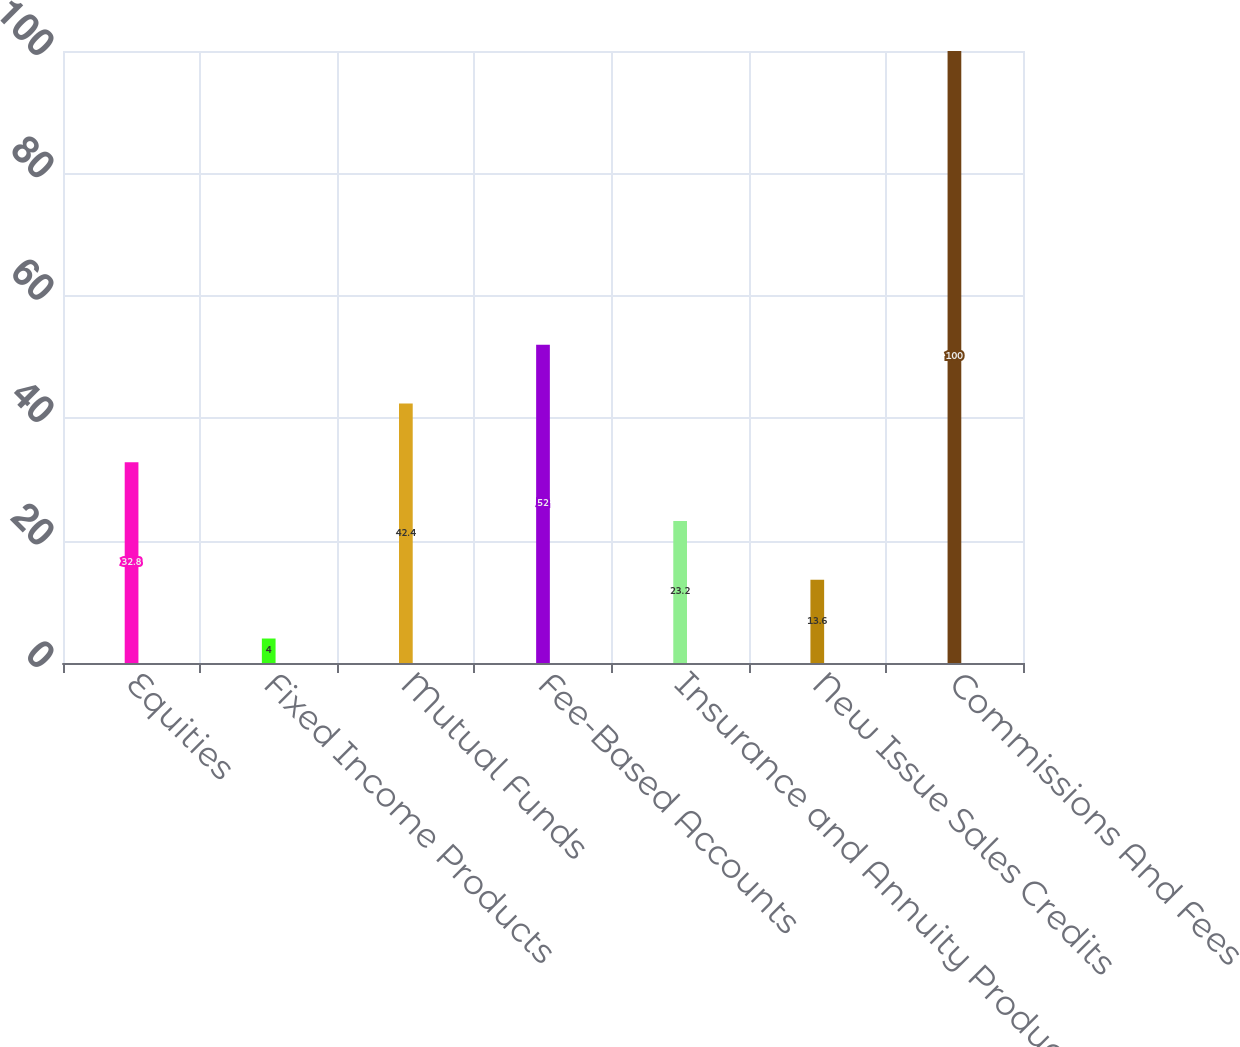Convert chart to OTSL. <chart><loc_0><loc_0><loc_500><loc_500><bar_chart><fcel>Equities<fcel>Fixed Income Products<fcel>Mutual Funds<fcel>Fee-Based Accounts<fcel>Insurance and Annuity Products<fcel>New Issue Sales Credits<fcel>Commissions And Fees<nl><fcel>32.8<fcel>4<fcel>42.4<fcel>52<fcel>23.2<fcel>13.6<fcel>100<nl></chart> 